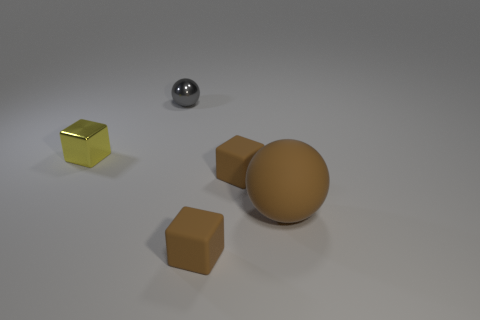Subtract 1 cubes. How many cubes are left? 2 Add 2 large brown matte balls. How many objects exist? 7 Subtract all balls. How many objects are left? 3 Subtract all matte things. Subtract all large brown rubber objects. How many objects are left? 1 Add 4 big brown objects. How many big brown objects are left? 5 Add 4 big purple cylinders. How many big purple cylinders exist? 4 Subtract 0 purple blocks. How many objects are left? 5 